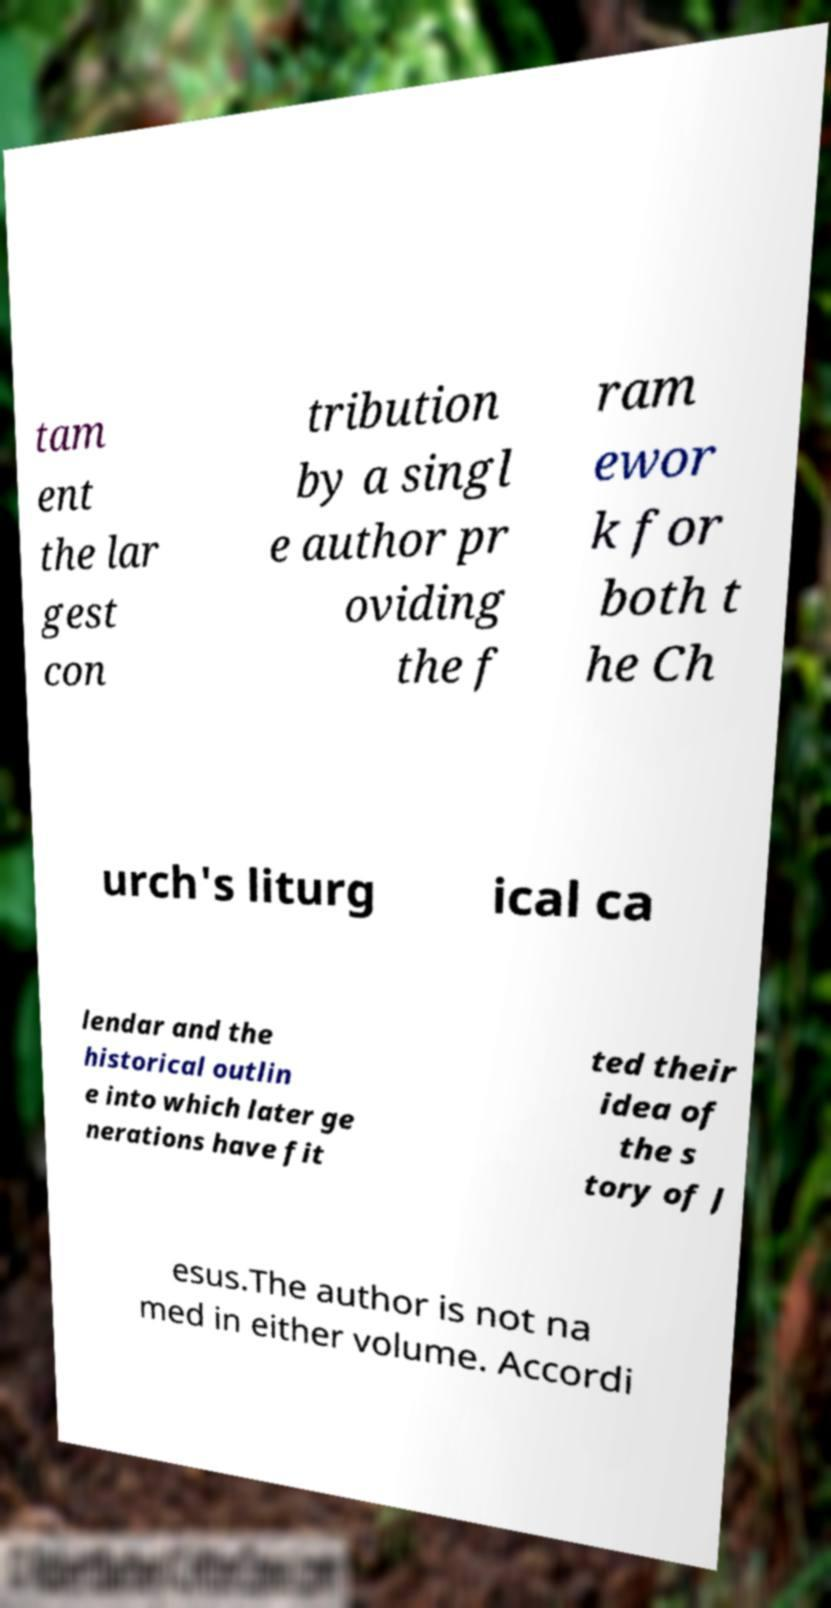Please identify and transcribe the text found in this image. tam ent the lar gest con tribution by a singl e author pr oviding the f ram ewor k for both t he Ch urch's liturg ical ca lendar and the historical outlin e into which later ge nerations have fit ted their idea of the s tory of J esus.The author is not na med in either volume. Accordi 